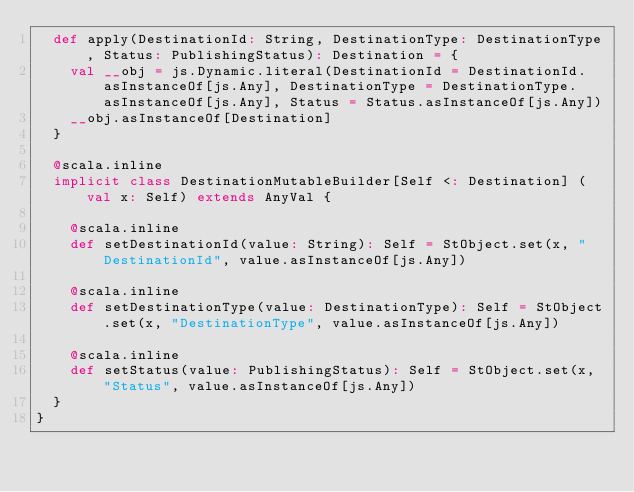<code> <loc_0><loc_0><loc_500><loc_500><_Scala_>  def apply(DestinationId: String, DestinationType: DestinationType, Status: PublishingStatus): Destination = {
    val __obj = js.Dynamic.literal(DestinationId = DestinationId.asInstanceOf[js.Any], DestinationType = DestinationType.asInstanceOf[js.Any], Status = Status.asInstanceOf[js.Any])
    __obj.asInstanceOf[Destination]
  }
  
  @scala.inline
  implicit class DestinationMutableBuilder[Self <: Destination] (val x: Self) extends AnyVal {
    
    @scala.inline
    def setDestinationId(value: String): Self = StObject.set(x, "DestinationId", value.asInstanceOf[js.Any])
    
    @scala.inline
    def setDestinationType(value: DestinationType): Self = StObject.set(x, "DestinationType", value.asInstanceOf[js.Any])
    
    @scala.inline
    def setStatus(value: PublishingStatus): Self = StObject.set(x, "Status", value.asInstanceOf[js.Any])
  }
}
</code> 